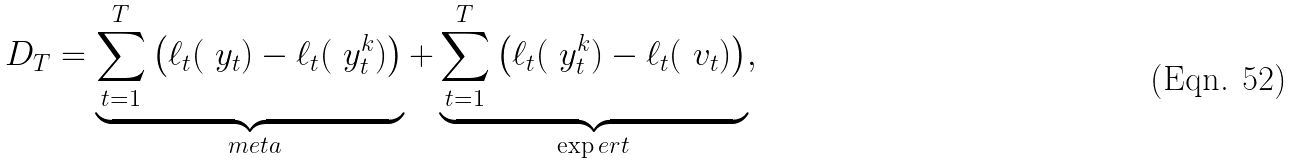Convert formula to latex. <formula><loc_0><loc_0><loc_500><loc_500>D _ { T } = \underbrace { \sum _ { t = 1 } ^ { T } \left ( \ell _ { t } ( \ y _ { t } ) - \ell _ { t } ( \ y _ { t } ^ { k } ) \right ) } _ { \ m e t a } + \underbrace { \sum _ { t = 1 } ^ { T } \left ( \ell _ { t } ( \ y _ { t } ^ { k } ) - \ell _ { t } ( \ v _ { t } ) \right ) } _ { \exp e r t } ,</formula> 